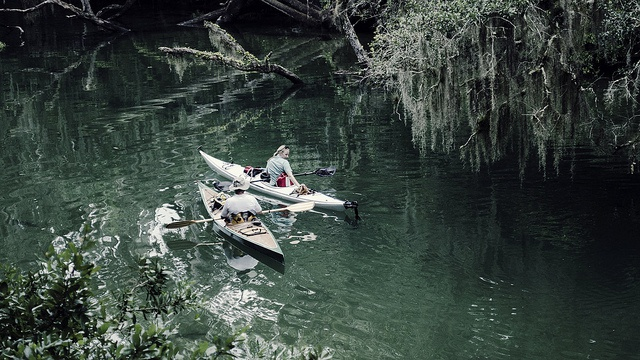Describe the objects in this image and their specific colors. I can see boat in black, white, darkgray, and gray tones, boat in black, lightgray, darkgray, and gray tones, people in black, lightgray, darkgray, and gray tones, and people in black, lightgray, darkgray, and gray tones in this image. 